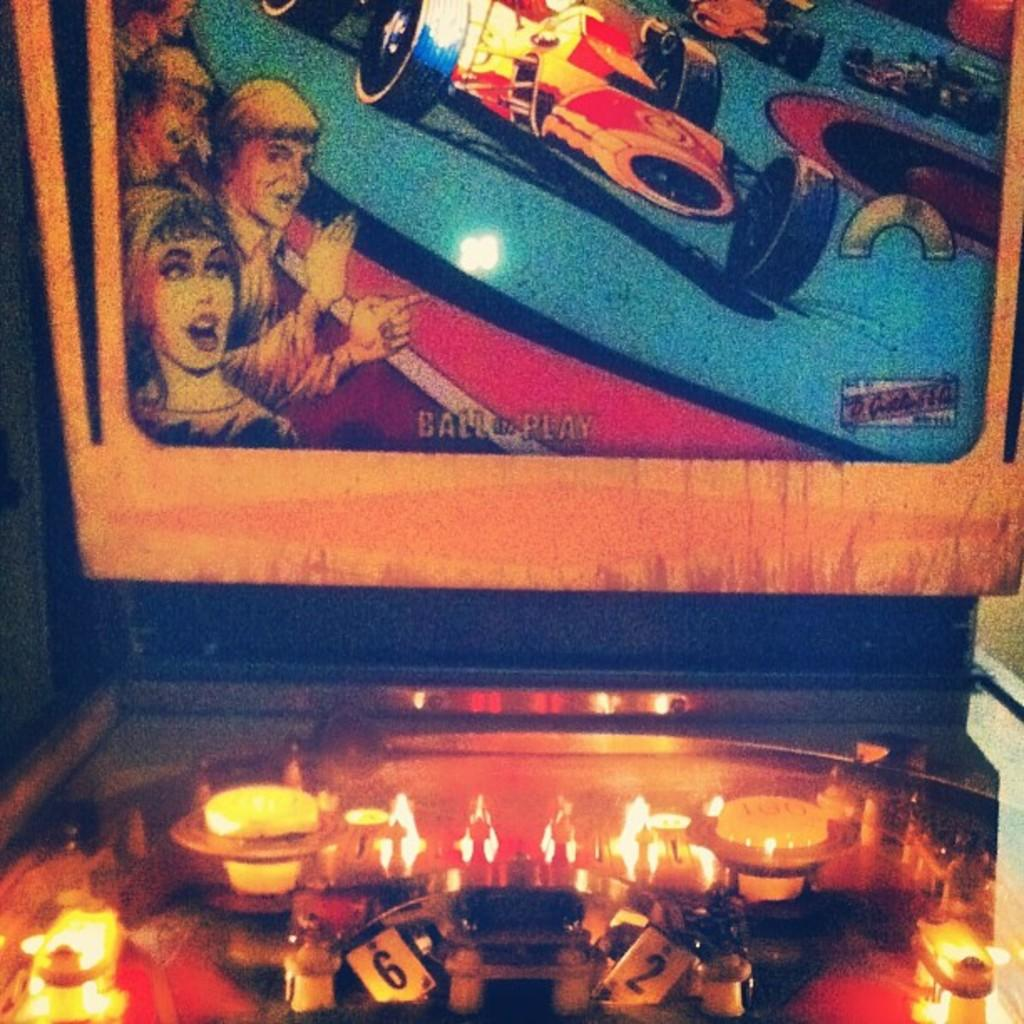What is the main object in the image? There is a board in the image. What else can be seen in the image besides the board? There are lights and other objects on the table in the image. What type of building can be seen on the coast in the image? There is no building or coast present in the image; it only features a board, lights, and other objects on a table. 